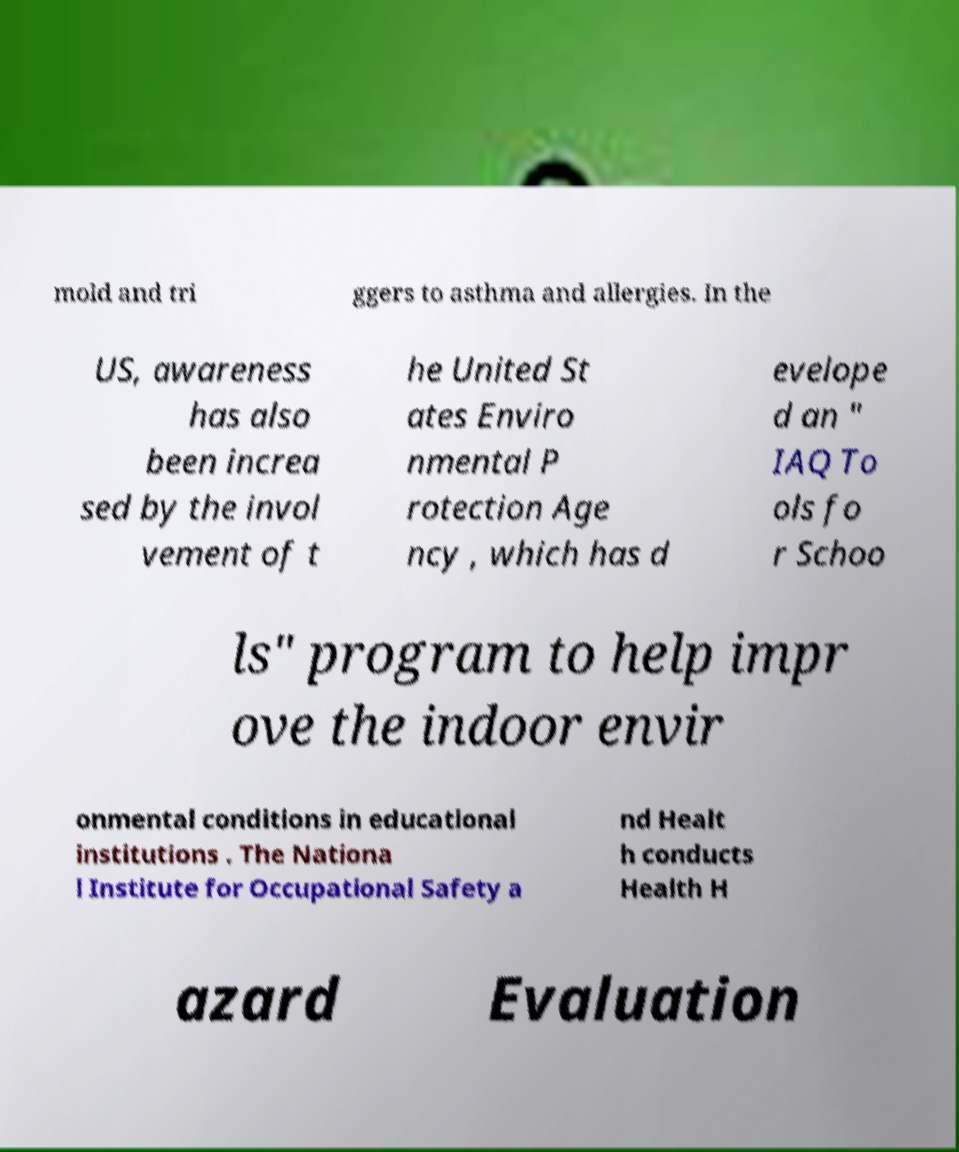Please read and relay the text visible in this image. What does it say? mold and tri ggers to asthma and allergies. In the US, awareness has also been increa sed by the invol vement of t he United St ates Enviro nmental P rotection Age ncy , which has d evelope d an " IAQ To ols fo r Schoo ls" program to help impr ove the indoor envir onmental conditions in educational institutions . The Nationa l Institute for Occupational Safety a nd Healt h conducts Health H azard Evaluation 